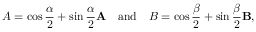<formula> <loc_0><loc_0><loc_500><loc_500>A = \cos { \frac { \alpha } { 2 } } + \sin { \frac { \alpha } { 2 } } A \quad a n d \quad B = \cos { \frac { \beta } { 2 } } + \sin { \frac { \beta } { 2 } } B ,</formula> 